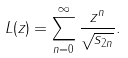Convert formula to latex. <formula><loc_0><loc_0><loc_500><loc_500>L ( z ) = \sum _ { n = 0 } ^ { \infty } \frac { z ^ { n } } { \sqrt { s _ { 2 n } } } .</formula> 